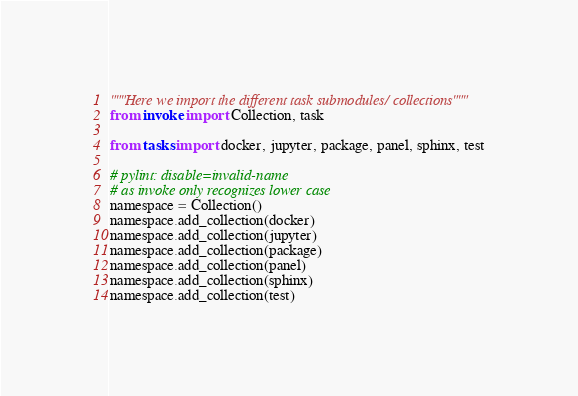<code> <loc_0><loc_0><loc_500><loc_500><_Python_>"""Here we import the different task submodules/ collections"""
from invoke import Collection, task

from tasks import docker, jupyter, package, panel, sphinx, test

# pylint: disable=invalid-name
# as invoke only recognizes lower case
namespace = Collection()
namespace.add_collection(docker)
namespace.add_collection(jupyter)
namespace.add_collection(package)
namespace.add_collection(panel)
namespace.add_collection(sphinx)
namespace.add_collection(test)
</code> 